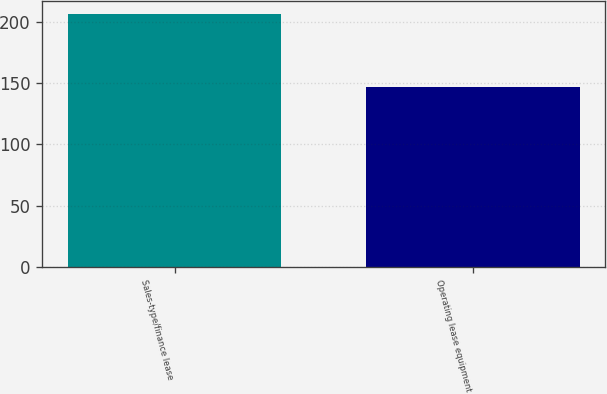<chart> <loc_0><loc_0><loc_500><loc_500><bar_chart><fcel>Sales-type/finance lease<fcel>Operating lease equipment<nl><fcel>207<fcel>147<nl></chart> 